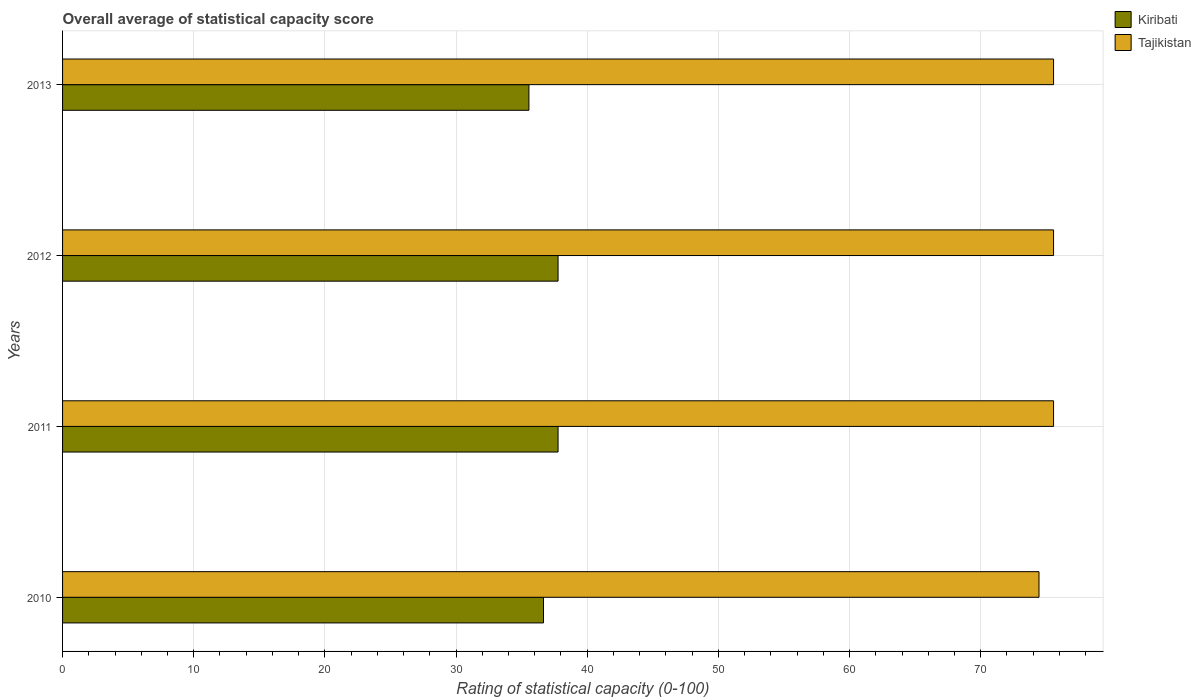How many different coloured bars are there?
Your answer should be very brief. 2. Are the number of bars per tick equal to the number of legend labels?
Your answer should be compact. Yes. How many bars are there on the 2nd tick from the top?
Offer a very short reply. 2. How many bars are there on the 4th tick from the bottom?
Provide a short and direct response. 2. In how many cases, is the number of bars for a given year not equal to the number of legend labels?
Your answer should be very brief. 0. What is the rating of statistical capacity in Tajikistan in 2010?
Keep it short and to the point. 74.44. Across all years, what is the maximum rating of statistical capacity in Kiribati?
Offer a very short reply. 37.78. Across all years, what is the minimum rating of statistical capacity in Tajikistan?
Offer a terse response. 74.44. In which year was the rating of statistical capacity in Kiribati minimum?
Offer a terse response. 2013. What is the total rating of statistical capacity in Kiribati in the graph?
Provide a succinct answer. 147.78. What is the difference between the rating of statistical capacity in Kiribati in 2012 and that in 2013?
Your response must be concise. 2.22. What is the difference between the rating of statistical capacity in Kiribati in 2011 and the rating of statistical capacity in Tajikistan in 2013?
Provide a succinct answer. -37.78. What is the average rating of statistical capacity in Tajikistan per year?
Offer a very short reply. 75.28. In the year 2012, what is the difference between the rating of statistical capacity in Kiribati and rating of statistical capacity in Tajikistan?
Keep it short and to the point. -37.78. What is the ratio of the rating of statistical capacity in Kiribati in 2010 to that in 2012?
Give a very brief answer. 0.97. Is the rating of statistical capacity in Tajikistan in 2010 less than that in 2013?
Offer a terse response. Yes. What is the difference between the highest and the second highest rating of statistical capacity in Tajikistan?
Your answer should be very brief. 0. What is the difference between the highest and the lowest rating of statistical capacity in Kiribati?
Ensure brevity in your answer.  2.22. Is the sum of the rating of statistical capacity in Kiribati in 2010 and 2011 greater than the maximum rating of statistical capacity in Tajikistan across all years?
Ensure brevity in your answer.  No. What does the 2nd bar from the top in 2010 represents?
Make the answer very short. Kiribati. What does the 2nd bar from the bottom in 2013 represents?
Provide a succinct answer. Tajikistan. What is the difference between two consecutive major ticks on the X-axis?
Offer a very short reply. 10. Does the graph contain grids?
Give a very brief answer. Yes. What is the title of the graph?
Your response must be concise. Overall average of statistical capacity score. Does "Kosovo" appear as one of the legend labels in the graph?
Provide a short and direct response. No. What is the label or title of the X-axis?
Your answer should be very brief. Rating of statistical capacity (0-100). What is the Rating of statistical capacity (0-100) in Kiribati in 2010?
Your answer should be compact. 36.67. What is the Rating of statistical capacity (0-100) of Tajikistan in 2010?
Provide a succinct answer. 74.44. What is the Rating of statistical capacity (0-100) in Kiribati in 2011?
Make the answer very short. 37.78. What is the Rating of statistical capacity (0-100) in Tajikistan in 2011?
Your answer should be very brief. 75.56. What is the Rating of statistical capacity (0-100) in Kiribati in 2012?
Offer a terse response. 37.78. What is the Rating of statistical capacity (0-100) of Tajikistan in 2012?
Your response must be concise. 75.56. What is the Rating of statistical capacity (0-100) of Kiribati in 2013?
Your response must be concise. 35.56. What is the Rating of statistical capacity (0-100) of Tajikistan in 2013?
Provide a short and direct response. 75.56. Across all years, what is the maximum Rating of statistical capacity (0-100) of Kiribati?
Offer a very short reply. 37.78. Across all years, what is the maximum Rating of statistical capacity (0-100) in Tajikistan?
Your answer should be very brief. 75.56. Across all years, what is the minimum Rating of statistical capacity (0-100) in Kiribati?
Your response must be concise. 35.56. Across all years, what is the minimum Rating of statistical capacity (0-100) in Tajikistan?
Ensure brevity in your answer.  74.44. What is the total Rating of statistical capacity (0-100) in Kiribati in the graph?
Your answer should be compact. 147.78. What is the total Rating of statistical capacity (0-100) in Tajikistan in the graph?
Give a very brief answer. 301.11. What is the difference between the Rating of statistical capacity (0-100) in Kiribati in 2010 and that in 2011?
Ensure brevity in your answer.  -1.11. What is the difference between the Rating of statistical capacity (0-100) of Tajikistan in 2010 and that in 2011?
Offer a very short reply. -1.11. What is the difference between the Rating of statistical capacity (0-100) in Kiribati in 2010 and that in 2012?
Provide a short and direct response. -1.11. What is the difference between the Rating of statistical capacity (0-100) in Tajikistan in 2010 and that in 2012?
Your response must be concise. -1.11. What is the difference between the Rating of statistical capacity (0-100) of Tajikistan in 2010 and that in 2013?
Your answer should be very brief. -1.11. What is the difference between the Rating of statistical capacity (0-100) of Kiribati in 2011 and that in 2012?
Your answer should be compact. 0. What is the difference between the Rating of statistical capacity (0-100) in Tajikistan in 2011 and that in 2012?
Offer a terse response. 0. What is the difference between the Rating of statistical capacity (0-100) of Kiribati in 2011 and that in 2013?
Offer a very short reply. 2.22. What is the difference between the Rating of statistical capacity (0-100) of Kiribati in 2012 and that in 2013?
Offer a very short reply. 2.22. What is the difference between the Rating of statistical capacity (0-100) of Kiribati in 2010 and the Rating of statistical capacity (0-100) of Tajikistan in 2011?
Your response must be concise. -38.89. What is the difference between the Rating of statistical capacity (0-100) in Kiribati in 2010 and the Rating of statistical capacity (0-100) in Tajikistan in 2012?
Your answer should be very brief. -38.89. What is the difference between the Rating of statistical capacity (0-100) of Kiribati in 2010 and the Rating of statistical capacity (0-100) of Tajikistan in 2013?
Offer a terse response. -38.89. What is the difference between the Rating of statistical capacity (0-100) of Kiribati in 2011 and the Rating of statistical capacity (0-100) of Tajikistan in 2012?
Offer a very short reply. -37.78. What is the difference between the Rating of statistical capacity (0-100) in Kiribati in 2011 and the Rating of statistical capacity (0-100) in Tajikistan in 2013?
Provide a short and direct response. -37.78. What is the difference between the Rating of statistical capacity (0-100) in Kiribati in 2012 and the Rating of statistical capacity (0-100) in Tajikistan in 2013?
Offer a terse response. -37.78. What is the average Rating of statistical capacity (0-100) of Kiribati per year?
Provide a succinct answer. 36.94. What is the average Rating of statistical capacity (0-100) of Tajikistan per year?
Provide a short and direct response. 75.28. In the year 2010, what is the difference between the Rating of statistical capacity (0-100) of Kiribati and Rating of statistical capacity (0-100) of Tajikistan?
Provide a succinct answer. -37.78. In the year 2011, what is the difference between the Rating of statistical capacity (0-100) in Kiribati and Rating of statistical capacity (0-100) in Tajikistan?
Offer a terse response. -37.78. In the year 2012, what is the difference between the Rating of statistical capacity (0-100) of Kiribati and Rating of statistical capacity (0-100) of Tajikistan?
Provide a succinct answer. -37.78. What is the ratio of the Rating of statistical capacity (0-100) of Kiribati in 2010 to that in 2011?
Your answer should be very brief. 0.97. What is the ratio of the Rating of statistical capacity (0-100) in Kiribati in 2010 to that in 2012?
Offer a very short reply. 0.97. What is the ratio of the Rating of statistical capacity (0-100) of Tajikistan in 2010 to that in 2012?
Offer a very short reply. 0.99. What is the ratio of the Rating of statistical capacity (0-100) of Kiribati in 2010 to that in 2013?
Make the answer very short. 1.03. What is the ratio of the Rating of statistical capacity (0-100) in Tajikistan in 2011 to that in 2012?
Keep it short and to the point. 1. What is the ratio of the Rating of statistical capacity (0-100) in Kiribati in 2011 to that in 2013?
Give a very brief answer. 1.06. What is the ratio of the Rating of statistical capacity (0-100) of Tajikistan in 2011 to that in 2013?
Your response must be concise. 1. What is the ratio of the Rating of statistical capacity (0-100) in Kiribati in 2012 to that in 2013?
Provide a succinct answer. 1.06. What is the difference between the highest and the second highest Rating of statistical capacity (0-100) in Kiribati?
Offer a terse response. 0. What is the difference between the highest and the second highest Rating of statistical capacity (0-100) in Tajikistan?
Provide a succinct answer. 0. What is the difference between the highest and the lowest Rating of statistical capacity (0-100) in Kiribati?
Your response must be concise. 2.22. 